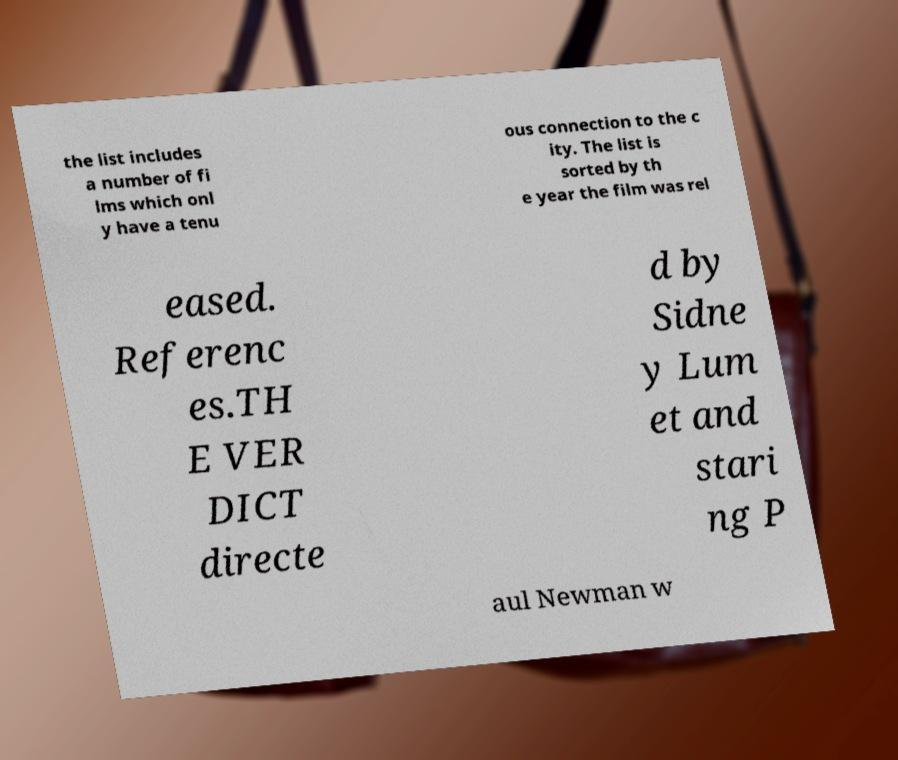Can you accurately transcribe the text from the provided image for me? the list includes a number of fi lms which onl y have a tenu ous connection to the c ity. The list is sorted by th e year the film was rel eased. Referenc es.TH E VER DICT directe d by Sidne y Lum et and stari ng P aul Newman w 